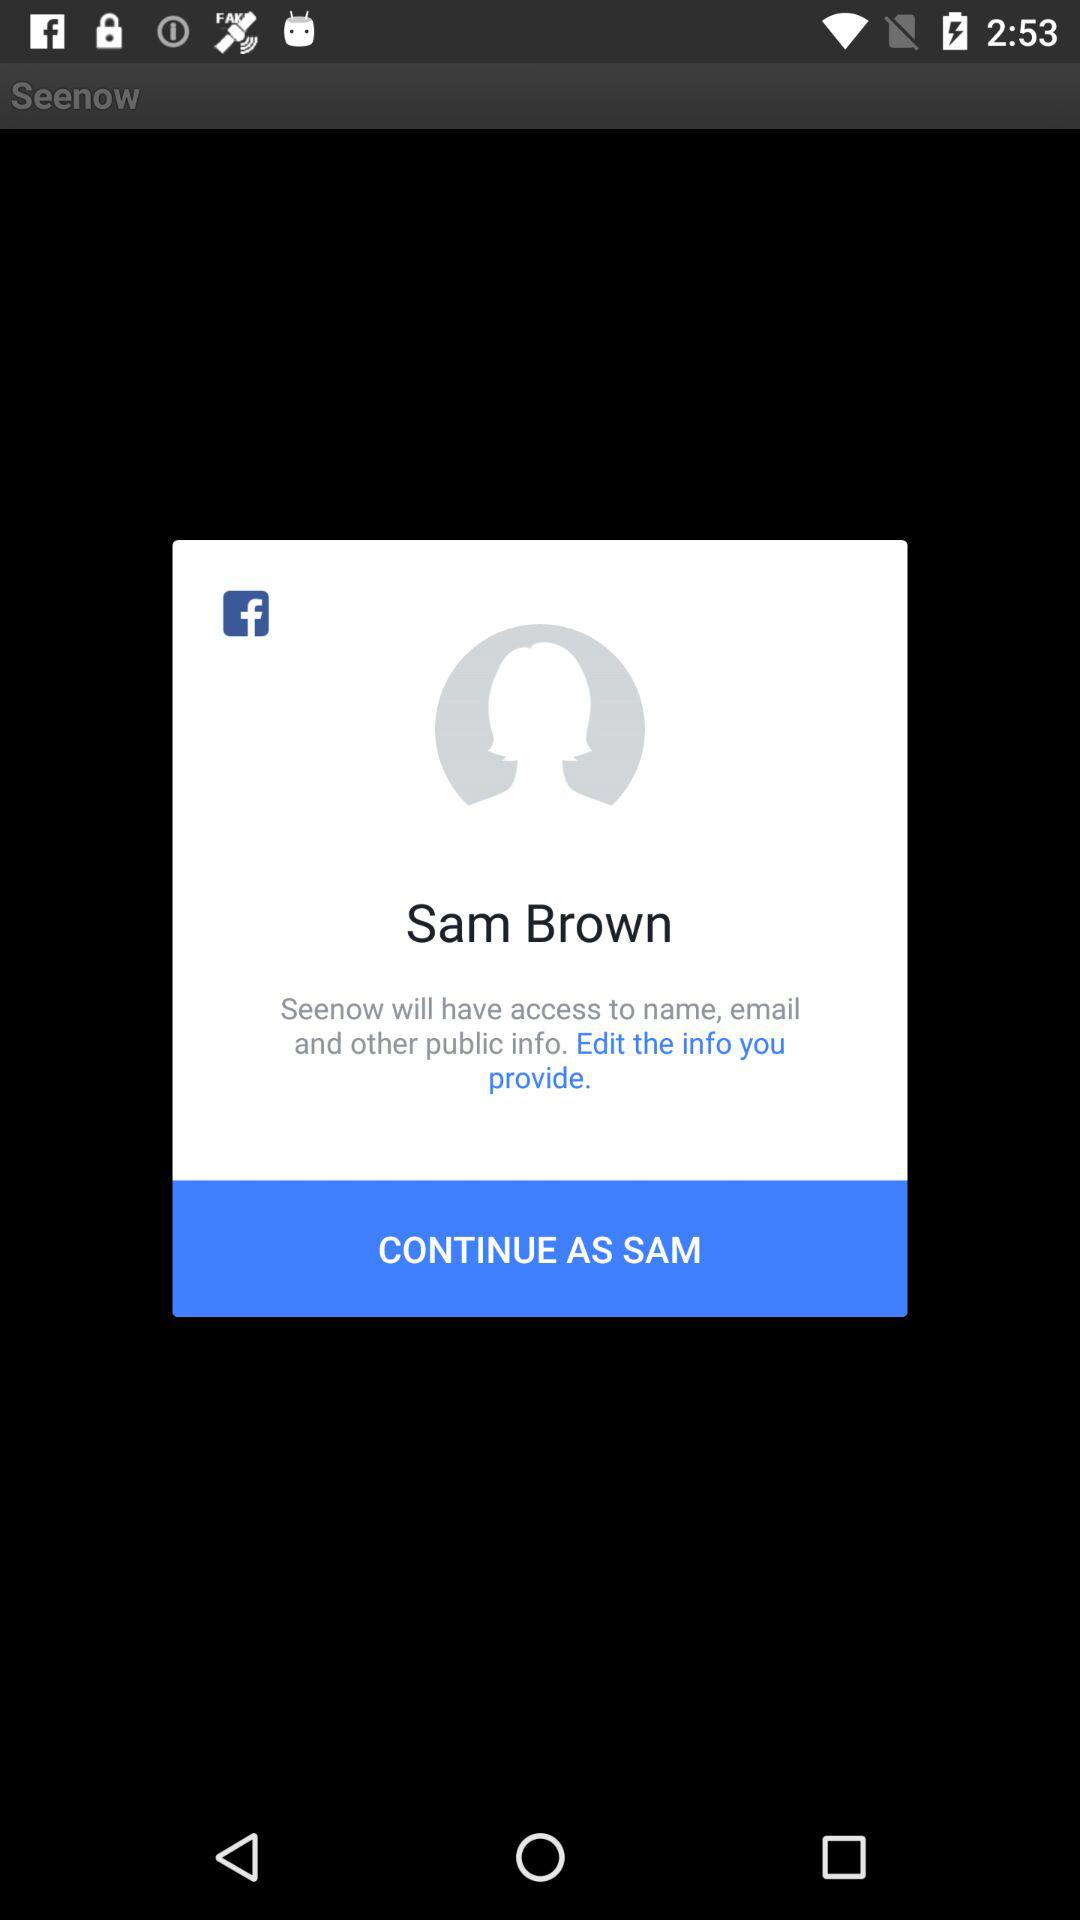What application is asking for permission? The application asking for permission is "Seenow". 